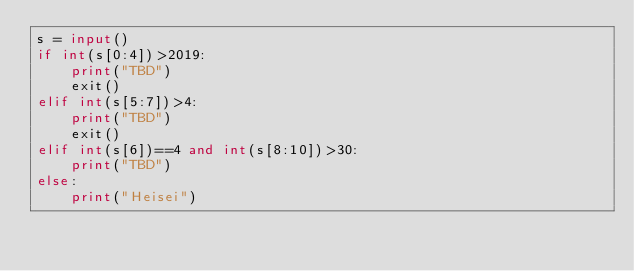<code> <loc_0><loc_0><loc_500><loc_500><_Python_>s = input()
if int(s[0:4])>2019:
    print("TBD")
    exit()
elif int(s[5:7])>4:
    print("TBD")
    exit()
elif int(s[6])==4 and int(s[8:10])>30:
    print("TBD")
else:
    print("Heisei")</code> 